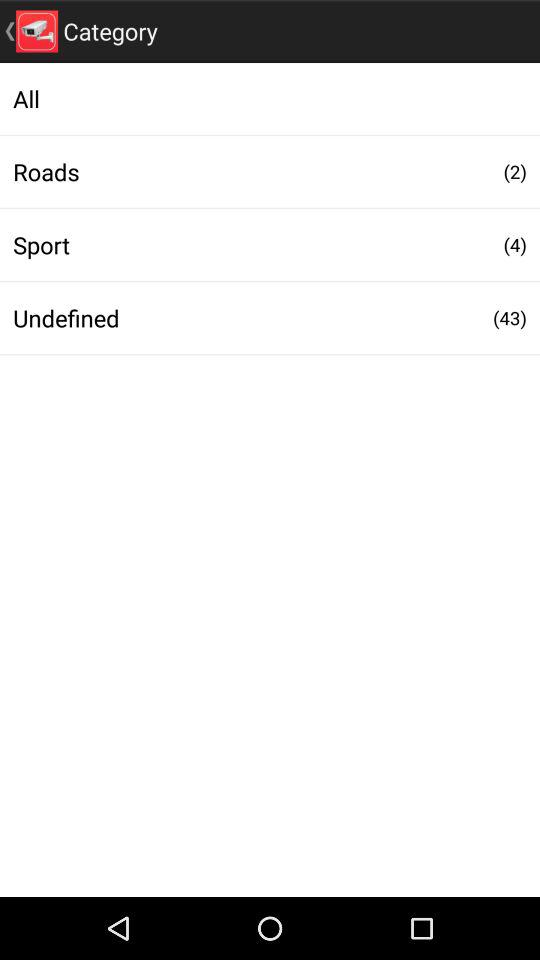How many more roads than sport are there?
Answer the question using a single word or phrase. 2 